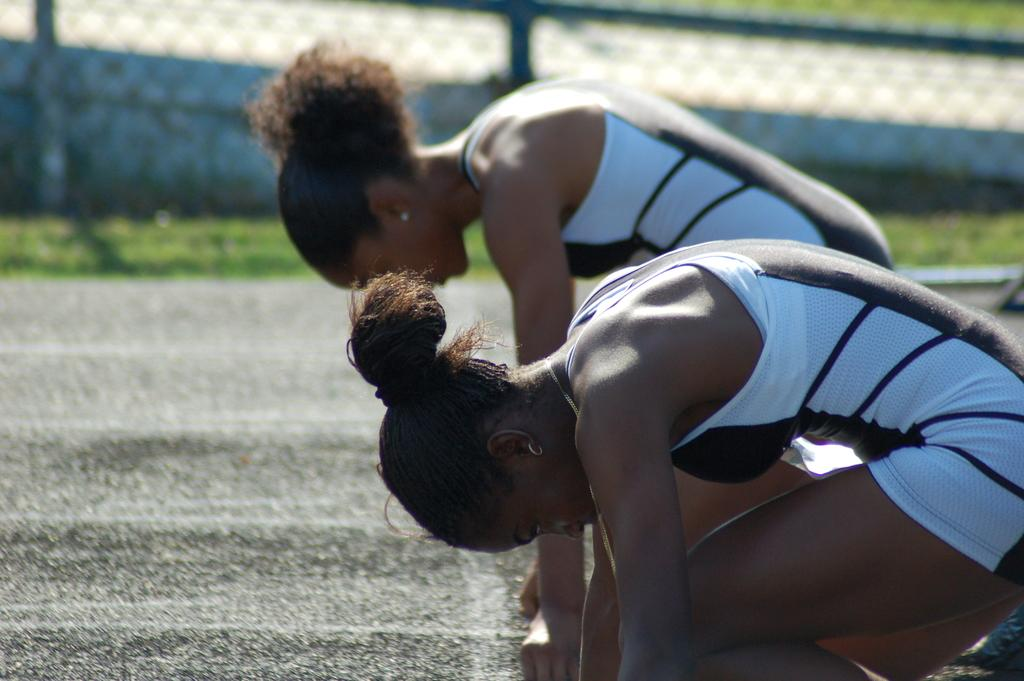How many people are in the image? There are two women in the image. Where are the women located in the image? The women are on the road in the image. What type of vegetation can be seen in the image? There is grass in the image. What is the structure visible in the image? There is a fence in the image. How would you describe the background of the image? The background of the image is blurry. What type of railway can be seen in the image? There is no railway present in the image. What is the zinc content of the grass in the image? The zinc content of the grass cannot be determined from the image. 